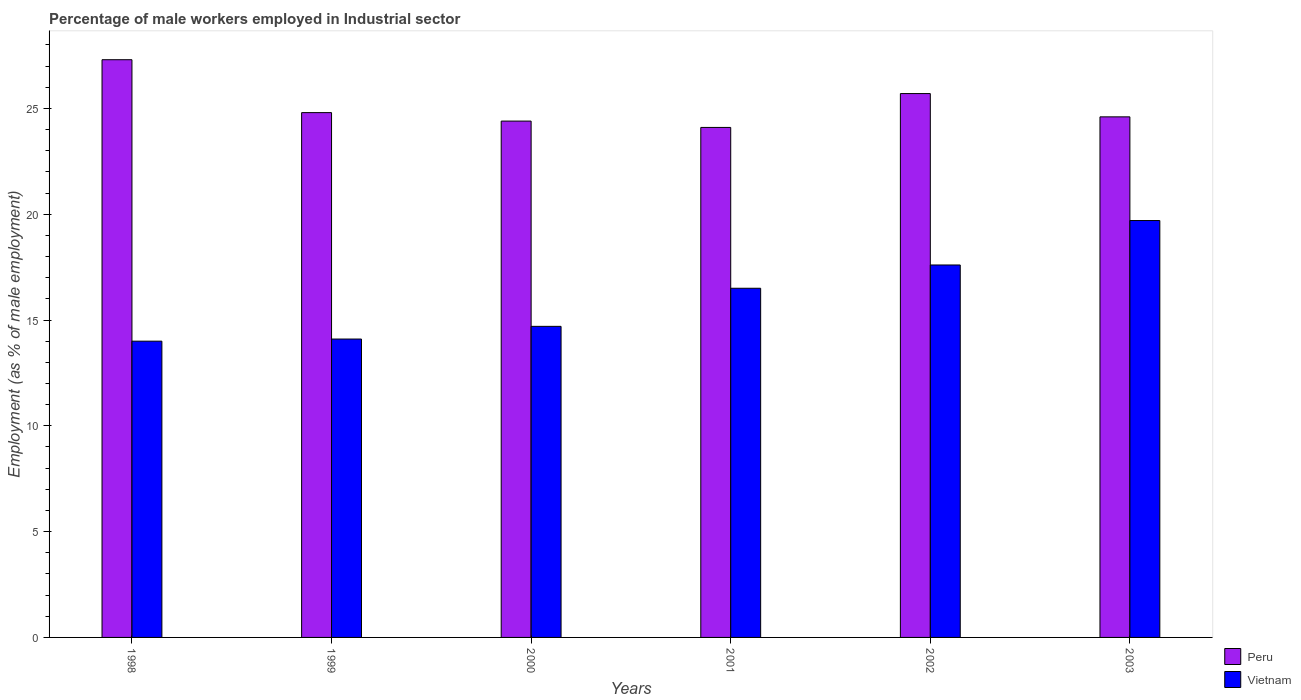How many different coloured bars are there?
Make the answer very short. 2. How many bars are there on the 1st tick from the left?
Give a very brief answer. 2. What is the label of the 2nd group of bars from the left?
Your response must be concise. 1999. What is the percentage of male workers employed in Industrial sector in Peru in 1999?
Ensure brevity in your answer.  24.8. Across all years, what is the maximum percentage of male workers employed in Industrial sector in Vietnam?
Your answer should be compact. 19.7. Across all years, what is the minimum percentage of male workers employed in Industrial sector in Peru?
Your response must be concise. 24.1. In which year was the percentage of male workers employed in Industrial sector in Peru maximum?
Give a very brief answer. 1998. What is the total percentage of male workers employed in Industrial sector in Peru in the graph?
Your answer should be very brief. 150.9. What is the difference between the percentage of male workers employed in Industrial sector in Vietnam in 1999 and that in 2001?
Provide a succinct answer. -2.4. What is the difference between the percentage of male workers employed in Industrial sector in Peru in 2000 and the percentage of male workers employed in Industrial sector in Vietnam in 1999?
Offer a very short reply. 10.3. What is the average percentage of male workers employed in Industrial sector in Vietnam per year?
Provide a succinct answer. 16.1. In the year 1998, what is the difference between the percentage of male workers employed in Industrial sector in Vietnam and percentage of male workers employed in Industrial sector in Peru?
Make the answer very short. -13.3. What is the ratio of the percentage of male workers employed in Industrial sector in Vietnam in 1998 to that in 2003?
Keep it short and to the point. 0.71. What is the difference between the highest and the second highest percentage of male workers employed in Industrial sector in Vietnam?
Keep it short and to the point. 2.1. What is the difference between the highest and the lowest percentage of male workers employed in Industrial sector in Peru?
Give a very brief answer. 3.2. Is the sum of the percentage of male workers employed in Industrial sector in Peru in 1998 and 2000 greater than the maximum percentage of male workers employed in Industrial sector in Vietnam across all years?
Your response must be concise. Yes. How many bars are there?
Give a very brief answer. 12. How many years are there in the graph?
Your answer should be very brief. 6. Are the values on the major ticks of Y-axis written in scientific E-notation?
Give a very brief answer. No. How many legend labels are there?
Offer a terse response. 2. How are the legend labels stacked?
Your response must be concise. Vertical. What is the title of the graph?
Your answer should be compact. Percentage of male workers employed in Industrial sector. What is the label or title of the X-axis?
Your answer should be compact. Years. What is the label or title of the Y-axis?
Provide a short and direct response. Employment (as % of male employment). What is the Employment (as % of male employment) of Peru in 1998?
Ensure brevity in your answer.  27.3. What is the Employment (as % of male employment) of Vietnam in 1998?
Provide a short and direct response. 14. What is the Employment (as % of male employment) of Peru in 1999?
Ensure brevity in your answer.  24.8. What is the Employment (as % of male employment) of Vietnam in 1999?
Ensure brevity in your answer.  14.1. What is the Employment (as % of male employment) of Peru in 2000?
Make the answer very short. 24.4. What is the Employment (as % of male employment) of Vietnam in 2000?
Offer a very short reply. 14.7. What is the Employment (as % of male employment) of Peru in 2001?
Make the answer very short. 24.1. What is the Employment (as % of male employment) of Vietnam in 2001?
Offer a terse response. 16.5. What is the Employment (as % of male employment) of Peru in 2002?
Ensure brevity in your answer.  25.7. What is the Employment (as % of male employment) in Vietnam in 2002?
Your response must be concise. 17.6. What is the Employment (as % of male employment) of Peru in 2003?
Give a very brief answer. 24.6. What is the Employment (as % of male employment) in Vietnam in 2003?
Give a very brief answer. 19.7. Across all years, what is the maximum Employment (as % of male employment) of Peru?
Make the answer very short. 27.3. Across all years, what is the maximum Employment (as % of male employment) of Vietnam?
Ensure brevity in your answer.  19.7. Across all years, what is the minimum Employment (as % of male employment) in Peru?
Your answer should be very brief. 24.1. Across all years, what is the minimum Employment (as % of male employment) in Vietnam?
Provide a short and direct response. 14. What is the total Employment (as % of male employment) of Peru in the graph?
Your response must be concise. 150.9. What is the total Employment (as % of male employment) of Vietnam in the graph?
Offer a very short reply. 96.6. What is the difference between the Employment (as % of male employment) in Peru in 1998 and that in 2000?
Your answer should be very brief. 2.9. What is the difference between the Employment (as % of male employment) of Vietnam in 1998 and that in 2000?
Your answer should be very brief. -0.7. What is the difference between the Employment (as % of male employment) in Vietnam in 1998 and that in 2001?
Keep it short and to the point. -2.5. What is the difference between the Employment (as % of male employment) in Peru in 1998 and that in 2002?
Keep it short and to the point. 1.6. What is the difference between the Employment (as % of male employment) in Vietnam in 1998 and that in 2002?
Offer a terse response. -3.6. What is the difference between the Employment (as % of male employment) in Vietnam in 1998 and that in 2003?
Offer a terse response. -5.7. What is the difference between the Employment (as % of male employment) in Peru in 1999 and that in 2000?
Offer a terse response. 0.4. What is the difference between the Employment (as % of male employment) in Peru in 1999 and that in 2003?
Keep it short and to the point. 0.2. What is the difference between the Employment (as % of male employment) in Peru in 2000 and that in 2001?
Make the answer very short. 0.3. What is the difference between the Employment (as % of male employment) in Vietnam in 2000 and that in 2002?
Offer a very short reply. -2.9. What is the difference between the Employment (as % of male employment) of Vietnam in 2000 and that in 2003?
Your answer should be very brief. -5. What is the difference between the Employment (as % of male employment) in Peru in 2001 and that in 2003?
Provide a short and direct response. -0.5. What is the difference between the Employment (as % of male employment) in Vietnam in 2001 and that in 2003?
Keep it short and to the point. -3.2. What is the difference between the Employment (as % of male employment) of Vietnam in 2002 and that in 2003?
Offer a very short reply. -2.1. What is the difference between the Employment (as % of male employment) of Peru in 1998 and the Employment (as % of male employment) of Vietnam in 1999?
Give a very brief answer. 13.2. What is the difference between the Employment (as % of male employment) of Peru in 1998 and the Employment (as % of male employment) of Vietnam in 2001?
Keep it short and to the point. 10.8. What is the difference between the Employment (as % of male employment) in Peru in 1998 and the Employment (as % of male employment) in Vietnam in 2003?
Make the answer very short. 7.6. What is the difference between the Employment (as % of male employment) of Peru in 1999 and the Employment (as % of male employment) of Vietnam in 2000?
Your answer should be very brief. 10.1. What is the difference between the Employment (as % of male employment) of Peru in 1999 and the Employment (as % of male employment) of Vietnam in 2001?
Give a very brief answer. 8.3. What is the difference between the Employment (as % of male employment) of Peru in 2001 and the Employment (as % of male employment) of Vietnam in 2003?
Offer a terse response. 4.4. What is the average Employment (as % of male employment) of Peru per year?
Make the answer very short. 25.15. What is the average Employment (as % of male employment) of Vietnam per year?
Ensure brevity in your answer.  16.1. In the year 1999, what is the difference between the Employment (as % of male employment) in Peru and Employment (as % of male employment) in Vietnam?
Give a very brief answer. 10.7. In the year 2001, what is the difference between the Employment (as % of male employment) of Peru and Employment (as % of male employment) of Vietnam?
Make the answer very short. 7.6. In the year 2003, what is the difference between the Employment (as % of male employment) of Peru and Employment (as % of male employment) of Vietnam?
Give a very brief answer. 4.9. What is the ratio of the Employment (as % of male employment) of Peru in 1998 to that in 1999?
Provide a short and direct response. 1.1. What is the ratio of the Employment (as % of male employment) in Vietnam in 1998 to that in 1999?
Make the answer very short. 0.99. What is the ratio of the Employment (as % of male employment) of Peru in 1998 to that in 2000?
Your response must be concise. 1.12. What is the ratio of the Employment (as % of male employment) of Peru in 1998 to that in 2001?
Your answer should be compact. 1.13. What is the ratio of the Employment (as % of male employment) of Vietnam in 1998 to that in 2001?
Your answer should be compact. 0.85. What is the ratio of the Employment (as % of male employment) of Peru in 1998 to that in 2002?
Provide a succinct answer. 1.06. What is the ratio of the Employment (as % of male employment) in Vietnam in 1998 to that in 2002?
Provide a succinct answer. 0.8. What is the ratio of the Employment (as % of male employment) in Peru in 1998 to that in 2003?
Your answer should be very brief. 1.11. What is the ratio of the Employment (as % of male employment) of Vietnam in 1998 to that in 2003?
Your response must be concise. 0.71. What is the ratio of the Employment (as % of male employment) of Peru in 1999 to that in 2000?
Offer a very short reply. 1.02. What is the ratio of the Employment (as % of male employment) in Vietnam in 1999 to that in 2000?
Your answer should be compact. 0.96. What is the ratio of the Employment (as % of male employment) in Vietnam in 1999 to that in 2001?
Your answer should be very brief. 0.85. What is the ratio of the Employment (as % of male employment) in Peru in 1999 to that in 2002?
Provide a succinct answer. 0.96. What is the ratio of the Employment (as % of male employment) of Vietnam in 1999 to that in 2002?
Your response must be concise. 0.8. What is the ratio of the Employment (as % of male employment) in Vietnam in 1999 to that in 2003?
Ensure brevity in your answer.  0.72. What is the ratio of the Employment (as % of male employment) in Peru in 2000 to that in 2001?
Provide a short and direct response. 1.01. What is the ratio of the Employment (as % of male employment) of Vietnam in 2000 to that in 2001?
Provide a short and direct response. 0.89. What is the ratio of the Employment (as % of male employment) in Peru in 2000 to that in 2002?
Make the answer very short. 0.95. What is the ratio of the Employment (as % of male employment) of Vietnam in 2000 to that in 2002?
Keep it short and to the point. 0.84. What is the ratio of the Employment (as % of male employment) of Vietnam in 2000 to that in 2003?
Ensure brevity in your answer.  0.75. What is the ratio of the Employment (as % of male employment) in Peru in 2001 to that in 2002?
Make the answer very short. 0.94. What is the ratio of the Employment (as % of male employment) in Vietnam in 2001 to that in 2002?
Keep it short and to the point. 0.94. What is the ratio of the Employment (as % of male employment) in Peru in 2001 to that in 2003?
Your response must be concise. 0.98. What is the ratio of the Employment (as % of male employment) of Vietnam in 2001 to that in 2003?
Your response must be concise. 0.84. What is the ratio of the Employment (as % of male employment) of Peru in 2002 to that in 2003?
Provide a succinct answer. 1.04. What is the ratio of the Employment (as % of male employment) of Vietnam in 2002 to that in 2003?
Your answer should be very brief. 0.89. What is the difference between the highest and the lowest Employment (as % of male employment) in Peru?
Your answer should be compact. 3.2. 